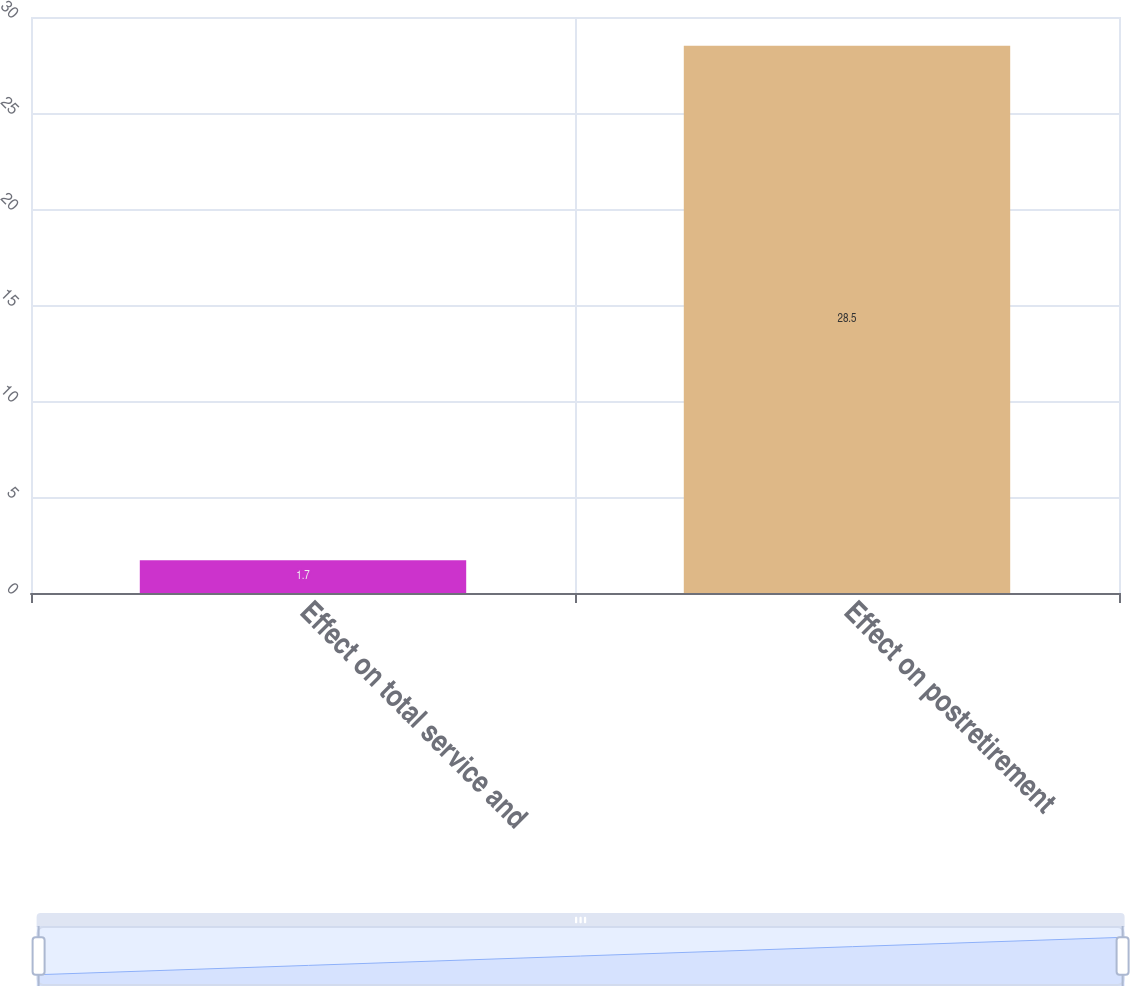Convert chart. <chart><loc_0><loc_0><loc_500><loc_500><bar_chart><fcel>Effect on total service and<fcel>Effect on postretirement<nl><fcel>1.7<fcel>28.5<nl></chart> 